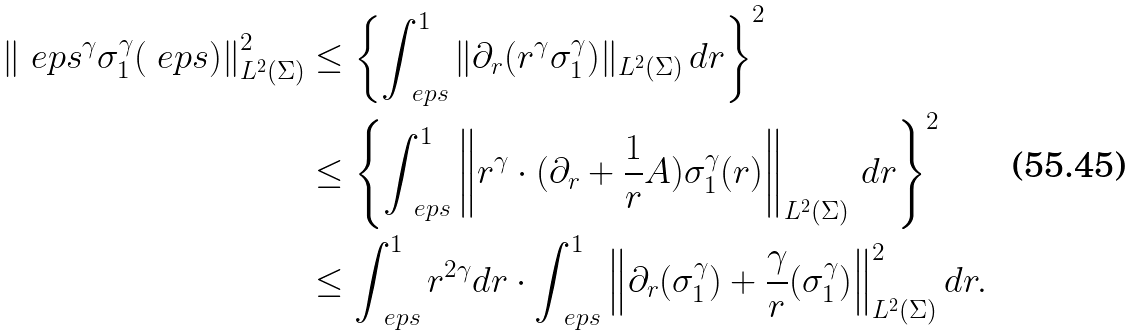Convert formula to latex. <formula><loc_0><loc_0><loc_500><loc_500>\left \| { \ e p s } ^ { \gamma } \sigma ^ { \gamma } _ { 1 } ( \ e p s ) \right \| ^ { 2 } _ { L ^ { 2 } ( \Sigma ) } & \leq \left \{ \int _ { \ e p s } ^ { 1 } \| \partial _ { r } ( r ^ { \gamma } \sigma _ { 1 } ^ { \gamma } ) \| _ { L ^ { 2 } ( \Sigma ) } \, d r \right \} ^ { 2 } \\ & \leq \left \{ \int _ { \ e p s } ^ { 1 } \left \| r ^ { \gamma } \cdot ( \partial _ { r } + \frac { 1 } { r } A ) \sigma _ { 1 } ^ { \gamma } ( r ) \right \| _ { L ^ { 2 } ( \Sigma ) } \, d r \right \} ^ { 2 } \\ & \leq \int _ { \ e p s } ^ { 1 } r ^ { 2 \gamma } d r \cdot \int _ { \ e p s } ^ { 1 } \left \| \partial _ { r } ( \sigma _ { 1 } ^ { \gamma } ) + \frac { \gamma } { r } ( \sigma _ { 1 } ^ { \gamma } ) \right \| ^ { 2 } _ { L ^ { 2 } ( \Sigma ) } d r .</formula> 